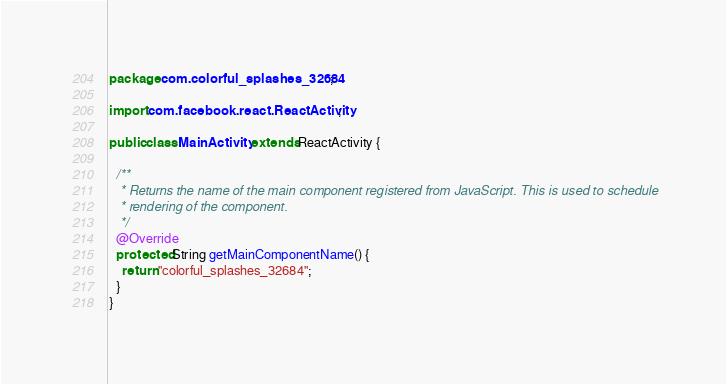<code> <loc_0><loc_0><loc_500><loc_500><_Java_>package com.colorful_splashes_32684;

import com.facebook.react.ReactActivity;

public class MainActivity extends ReactActivity {

  /**
   * Returns the name of the main component registered from JavaScript. This is used to schedule
   * rendering of the component.
   */
  @Override
  protected String getMainComponentName() {
    return "colorful_splashes_32684";
  }
}
</code> 